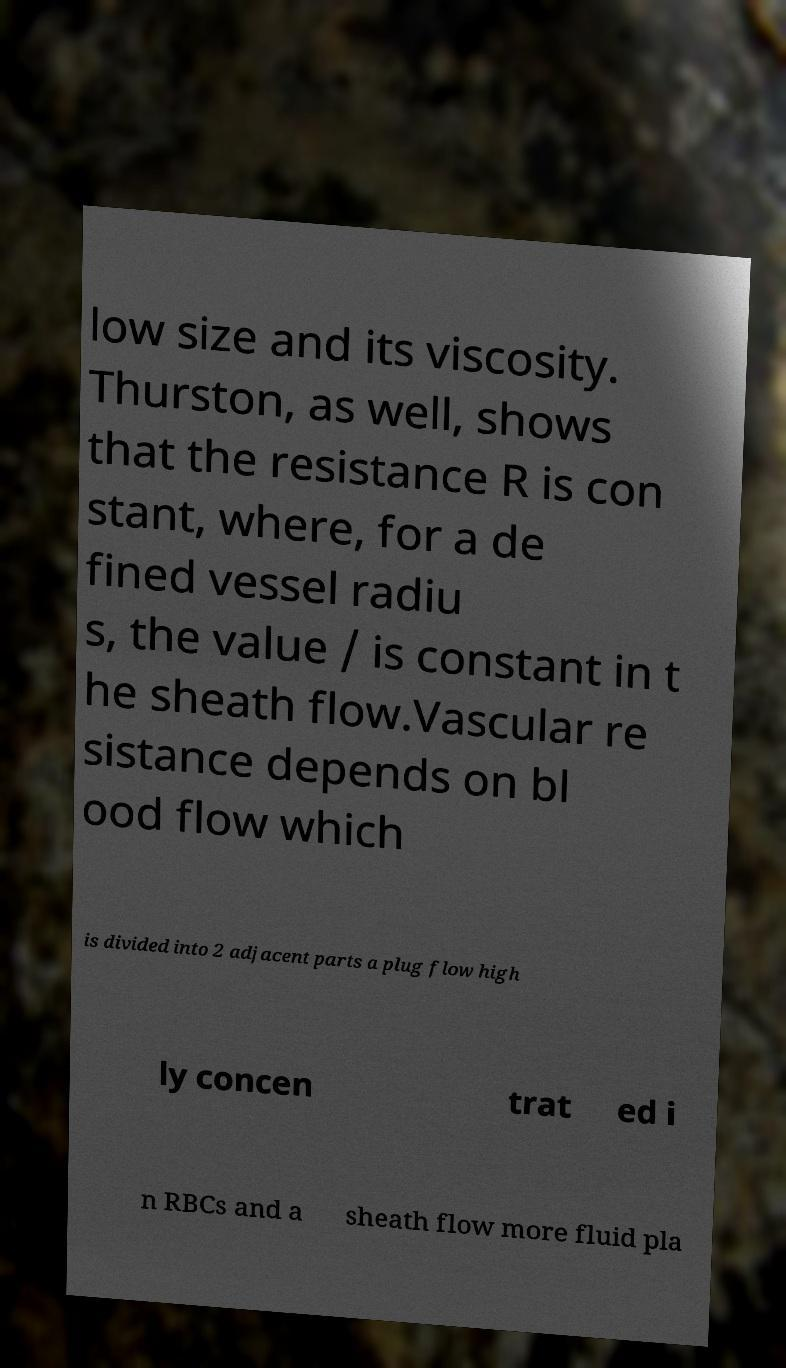I need the written content from this picture converted into text. Can you do that? low size and its viscosity. Thurston, as well, shows that the resistance R is con stant, where, for a de fined vessel radiu s, the value / is constant in t he sheath flow.Vascular re sistance depends on bl ood flow which is divided into 2 adjacent parts a plug flow high ly concen trat ed i n RBCs and a sheath flow more fluid pla 